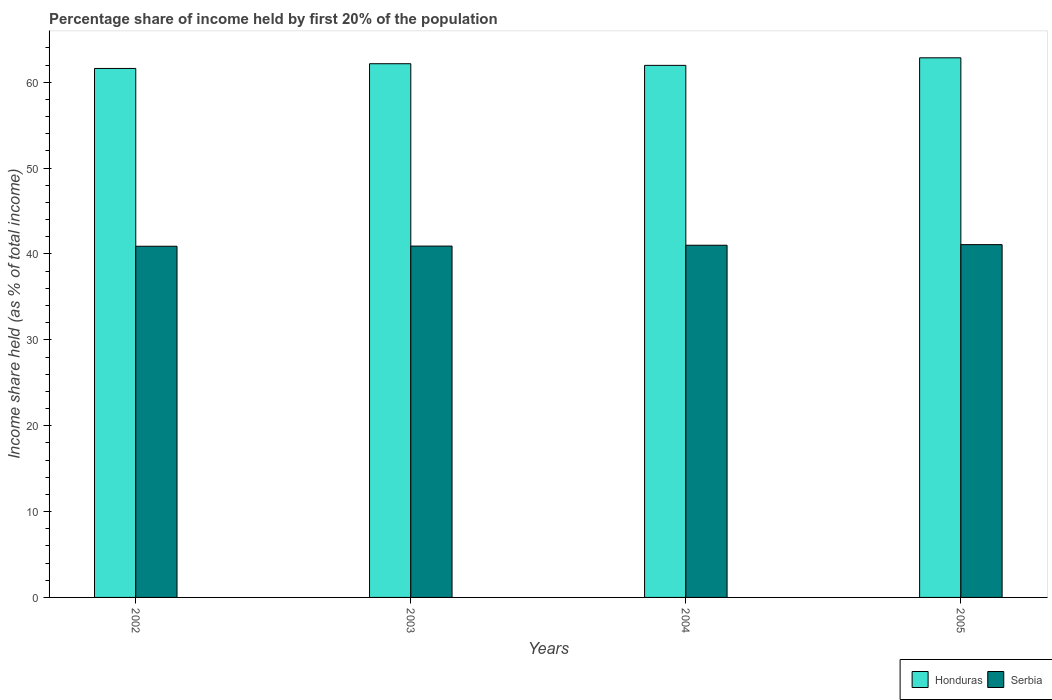How many groups of bars are there?
Your answer should be compact. 4. Are the number of bars per tick equal to the number of legend labels?
Your response must be concise. Yes. What is the label of the 3rd group of bars from the left?
Your response must be concise. 2004. What is the share of income held by first 20% of the population in Honduras in 2004?
Provide a succinct answer. 61.97. Across all years, what is the maximum share of income held by first 20% of the population in Serbia?
Your answer should be very brief. 41.09. Across all years, what is the minimum share of income held by first 20% of the population in Honduras?
Your answer should be compact. 61.61. What is the total share of income held by first 20% of the population in Honduras in the graph?
Provide a short and direct response. 248.59. What is the difference between the share of income held by first 20% of the population in Honduras in 2003 and that in 2005?
Provide a short and direct response. -0.69. What is the difference between the share of income held by first 20% of the population in Honduras in 2003 and the share of income held by first 20% of the population in Serbia in 2004?
Give a very brief answer. 21.14. What is the average share of income held by first 20% of the population in Serbia per year?
Provide a succinct answer. 40.98. In the year 2004, what is the difference between the share of income held by first 20% of the population in Honduras and share of income held by first 20% of the population in Serbia?
Ensure brevity in your answer.  20.95. What is the ratio of the share of income held by first 20% of the population in Serbia in 2002 to that in 2004?
Offer a very short reply. 1. Is the share of income held by first 20% of the population in Honduras in 2002 less than that in 2003?
Offer a very short reply. Yes. What is the difference between the highest and the second highest share of income held by first 20% of the population in Serbia?
Make the answer very short. 0.07. What is the difference between the highest and the lowest share of income held by first 20% of the population in Serbia?
Provide a succinct answer. 0.19. What does the 1st bar from the left in 2002 represents?
Offer a very short reply. Honduras. What does the 2nd bar from the right in 2004 represents?
Your answer should be compact. Honduras. How many bars are there?
Keep it short and to the point. 8. How many years are there in the graph?
Give a very brief answer. 4. What is the difference between two consecutive major ticks on the Y-axis?
Give a very brief answer. 10. Does the graph contain grids?
Keep it short and to the point. No. How many legend labels are there?
Keep it short and to the point. 2. How are the legend labels stacked?
Provide a short and direct response. Horizontal. What is the title of the graph?
Make the answer very short. Percentage share of income held by first 20% of the population. What is the label or title of the X-axis?
Offer a terse response. Years. What is the label or title of the Y-axis?
Your answer should be very brief. Income share held (as % of total income). What is the Income share held (as % of total income) in Honduras in 2002?
Offer a terse response. 61.61. What is the Income share held (as % of total income) in Serbia in 2002?
Your response must be concise. 40.9. What is the Income share held (as % of total income) of Honduras in 2003?
Your response must be concise. 62.16. What is the Income share held (as % of total income) of Serbia in 2003?
Ensure brevity in your answer.  40.92. What is the Income share held (as % of total income) in Honduras in 2004?
Your answer should be very brief. 61.97. What is the Income share held (as % of total income) in Serbia in 2004?
Provide a succinct answer. 41.02. What is the Income share held (as % of total income) of Honduras in 2005?
Provide a short and direct response. 62.85. What is the Income share held (as % of total income) of Serbia in 2005?
Your answer should be compact. 41.09. Across all years, what is the maximum Income share held (as % of total income) in Honduras?
Your response must be concise. 62.85. Across all years, what is the maximum Income share held (as % of total income) in Serbia?
Provide a succinct answer. 41.09. Across all years, what is the minimum Income share held (as % of total income) of Honduras?
Your answer should be compact. 61.61. Across all years, what is the minimum Income share held (as % of total income) of Serbia?
Ensure brevity in your answer.  40.9. What is the total Income share held (as % of total income) in Honduras in the graph?
Provide a short and direct response. 248.59. What is the total Income share held (as % of total income) of Serbia in the graph?
Provide a short and direct response. 163.93. What is the difference between the Income share held (as % of total income) in Honduras in 2002 and that in 2003?
Give a very brief answer. -0.55. What is the difference between the Income share held (as % of total income) of Serbia in 2002 and that in 2003?
Your answer should be very brief. -0.02. What is the difference between the Income share held (as % of total income) of Honduras in 2002 and that in 2004?
Make the answer very short. -0.36. What is the difference between the Income share held (as % of total income) of Serbia in 2002 and that in 2004?
Offer a very short reply. -0.12. What is the difference between the Income share held (as % of total income) in Honduras in 2002 and that in 2005?
Offer a very short reply. -1.24. What is the difference between the Income share held (as % of total income) in Serbia in 2002 and that in 2005?
Offer a very short reply. -0.19. What is the difference between the Income share held (as % of total income) in Honduras in 2003 and that in 2004?
Your response must be concise. 0.19. What is the difference between the Income share held (as % of total income) in Honduras in 2003 and that in 2005?
Ensure brevity in your answer.  -0.69. What is the difference between the Income share held (as % of total income) of Serbia in 2003 and that in 2005?
Your answer should be compact. -0.17. What is the difference between the Income share held (as % of total income) of Honduras in 2004 and that in 2005?
Provide a succinct answer. -0.88. What is the difference between the Income share held (as % of total income) in Serbia in 2004 and that in 2005?
Your answer should be compact. -0.07. What is the difference between the Income share held (as % of total income) in Honduras in 2002 and the Income share held (as % of total income) in Serbia in 2003?
Your response must be concise. 20.69. What is the difference between the Income share held (as % of total income) of Honduras in 2002 and the Income share held (as % of total income) of Serbia in 2004?
Your answer should be compact. 20.59. What is the difference between the Income share held (as % of total income) in Honduras in 2002 and the Income share held (as % of total income) in Serbia in 2005?
Provide a short and direct response. 20.52. What is the difference between the Income share held (as % of total income) in Honduras in 2003 and the Income share held (as % of total income) in Serbia in 2004?
Ensure brevity in your answer.  21.14. What is the difference between the Income share held (as % of total income) in Honduras in 2003 and the Income share held (as % of total income) in Serbia in 2005?
Offer a very short reply. 21.07. What is the difference between the Income share held (as % of total income) in Honduras in 2004 and the Income share held (as % of total income) in Serbia in 2005?
Your response must be concise. 20.88. What is the average Income share held (as % of total income) of Honduras per year?
Keep it short and to the point. 62.15. What is the average Income share held (as % of total income) in Serbia per year?
Your answer should be compact. 40.98. In the year 2002, what is the difference between the Income share held (as % of total income) of Honduras and Income share held (as % of total income) of Serbia?
Offer a terse response. 20.71. In the year 2003, what is the difference between the Income share held (as % of total income) in Honduras and Income share held (as % of total income) in Serbia?
Your response must be concise. 21.24. In the year 2004, what is the difference between the Income share held (as % of total income) in Honduras and Income share held (as % of total income) in Serbia?
Your answer should be compact. 20.95. In the year 2005, what is the difference between the Income share held (as % of total income) of Honduras and Income share held (as % of total income) of Serbia?
Your answer should be compact. 21.76. What is the ratio of the Income share held (as % of total income) in Honduras in 2002 to that in 2003?
Make the answer very short. 0.99. What is the ratio of the Income share held (as % of total income) of Serbia in 2002 to that in 2003?
Your response must be concise. 1. What is the ratio of the Income share held (as % of total income) in Serbia in 2002 to that in 2004?
Give a very brief answer. 1. What is the ratio of the Income share held (as % of total income) in Honduras in 2002 to that in 2005?
Provide a succinct answer. 0.98. What is the ratio of the Income share held (as % of total income) of Serbia in 2002 to that in 2005?
Provide a short and direct response. 1. What is the ratio of the Income share held (as % of total income) in Honduras in 2003 to that in 2004?
Offer a very short reply. 1. What is the ratio of the Income share held (as % of total income) in Honduras in 2003 to that in 2005?
Provide a succinct answer. 0.99. What is the ratio of the Income share held (as % of total income) of Honduras in 2004 to that in 2005?
Your answer should be compact. 0.99. What is the difference between the highest and the second highest Income share held (as % of total income) in Honduras?
Offer a terse response. 0.69. What is the difference between the highest and the second highest Income share held (as % of total income) of Serbia?
Make the answer very short. 0.07. What is the difference between the highest and the lowest Income share held (as % of total income) of Honduras?
Offer a terse response. 1.24. What is the difference between the highest and the lowest Income share held (as % of total income) in Serbia?
Ensure brevity in your answer.  0.19. 